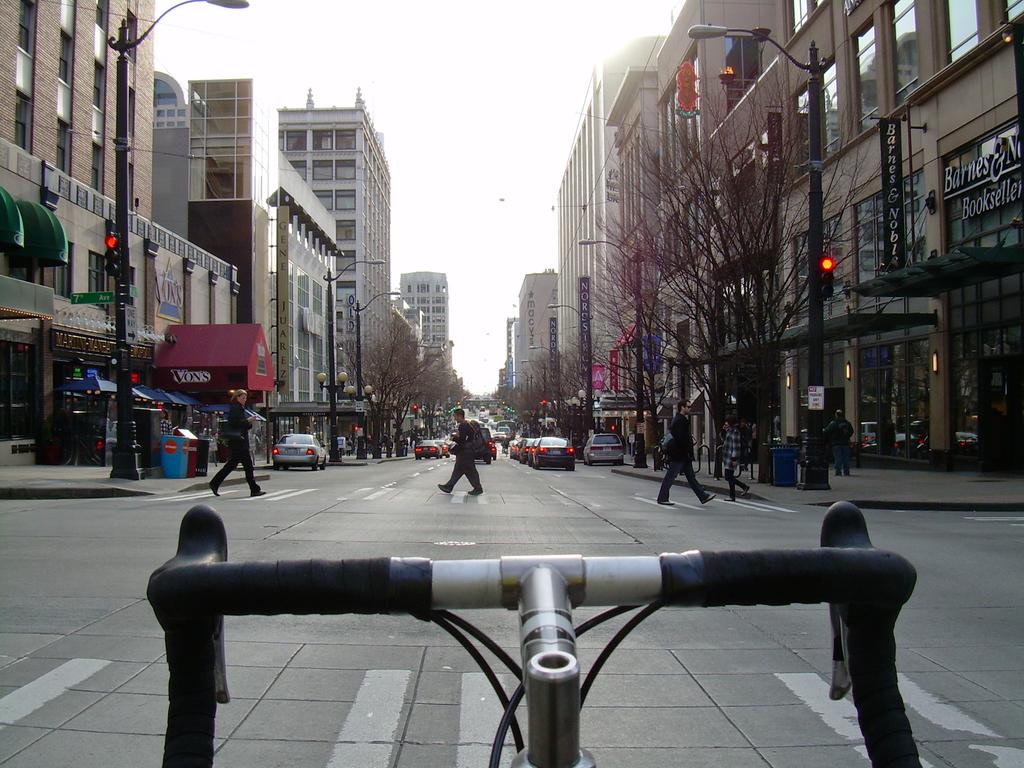What type of structures can be seen in the image? There is a group of buildings in the image. What is located in front of the buildings? Trees and vehicles are visible in front of the buildings. What type of objects are present in the image for lighting purposes? There are poles with lights in the image. What objects are present for waste disposal? Dustbins are present in the image. Can you describe the person visible in the image? A person is visible in the image. What is visible at the top of the image? The sky is visible at the top of the image. How many oranges are being held by the person in the image? There are no oranges visible in the image, and the person is not holding any. 